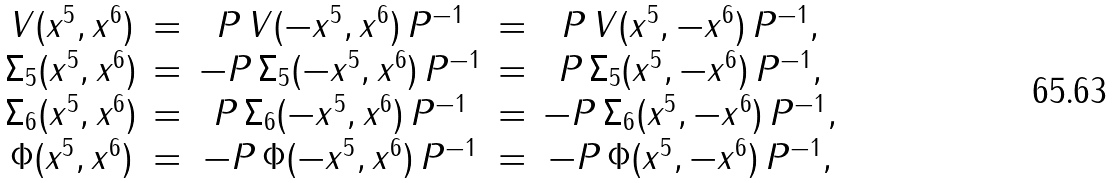<formula> <loc_0><loc_0><loc_500><loc_500>\begin{array} { c c c c c } V ( x ^ { 5 } , x ^ { 6 } ) & = & P \, V ( - x ^ { 5 } , x ^ { 6 } ) \, P ^ { - 1 } & = & P \, V ( x ^ { 5 } , - x ^ { 6 } ) \, P ^ { - 1 } , \\ \Sigma _ { 5 } ( x ^ { 5 } , x ^ { 6 } ) & = & - P \, \Sigma _ { 5 } ( - x ^ { 5 } , x ^ { 6 } ) \, P ^ { - 1 } & = & P \, \Sigma _ { 5 } ( x ^ { 5 } , - x ^ { 6 } ) \, P ^ { - 1 } , \\ \Sigma _ { 6 } ( x ^ { 5 } , x ^ { 6 } ) & = & P \, \Sigma _ { 6 } ( - x ^ { 5 } , x ^ { 6 } ) \, P ^ { - 1 } & = & - P \, \Sigma _ { 6 } ( x ^ { 5 } , - x ^ { 6 } ) \, P ^ { - 1 } , \\ \Phi ( x ^ { 5 } , x ^ { 6 } ) & = & - P \, \Phi ( - x ^ { 5 } , x ^ { 6 } ) \, P ^ { - 1 } & = & - P \, \Phi ( x ^ { 5 } , - x ^ { 6 } ) \, P ^ { - 1 } , \end{array}</formula> 